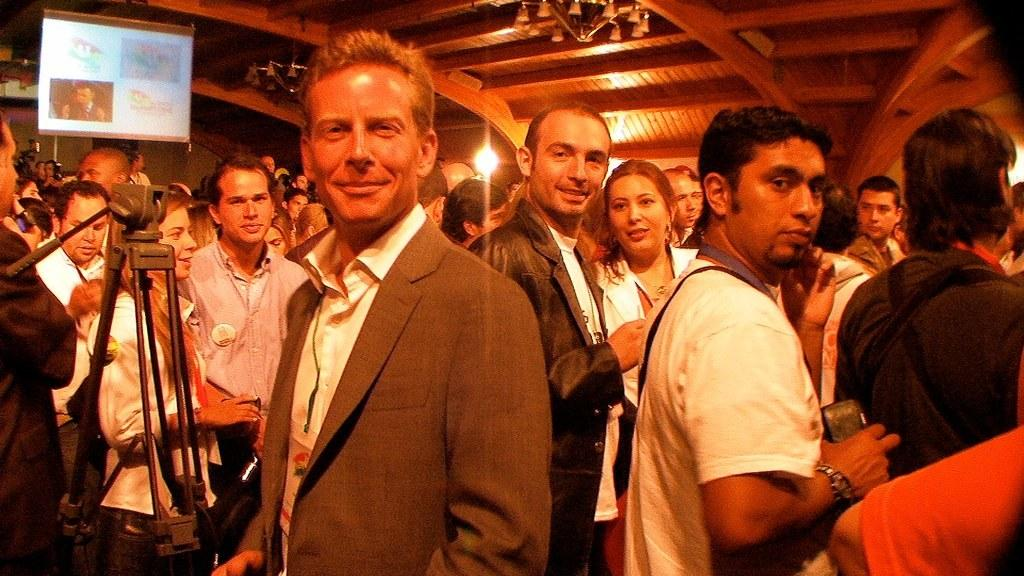How many people are in the image? There is a group of persons standing in the image. What can be seen on the roof in the image? There is a chandelier and a light on the roof. Where is the camera located in the image? The camera is on the left side of the image. What is present on the left side of the image besides the camera? There is a screen on the left side of the image. What type of cough medicine is visible on the screen in the image? There is no cough medicine or reference to a cough in the image. Is there a field visible in the image? No, there is no field present in the image. 